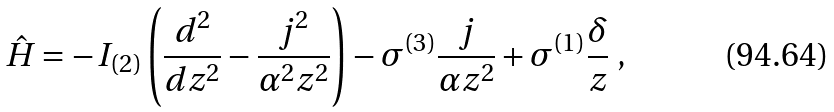Convert formula to latex. <formula><loc_0><loc_0><loc_500><loc_500>\hat { H } = - I _ { ( 2 ) } \left ( \frac { d ^ { 2 } } { d z ^ { 2 } } - \frac { j ^ { 2 } } { \alpha ^ { 2 } z ^ { 2 } } \right ) - \sigma ^ { ( 3 ) } \frac { j } { \alpha z ^ { 2 } } + \sigma ^ { ( 1 ) } \frac { \delta } { z } \ ,</formula> 